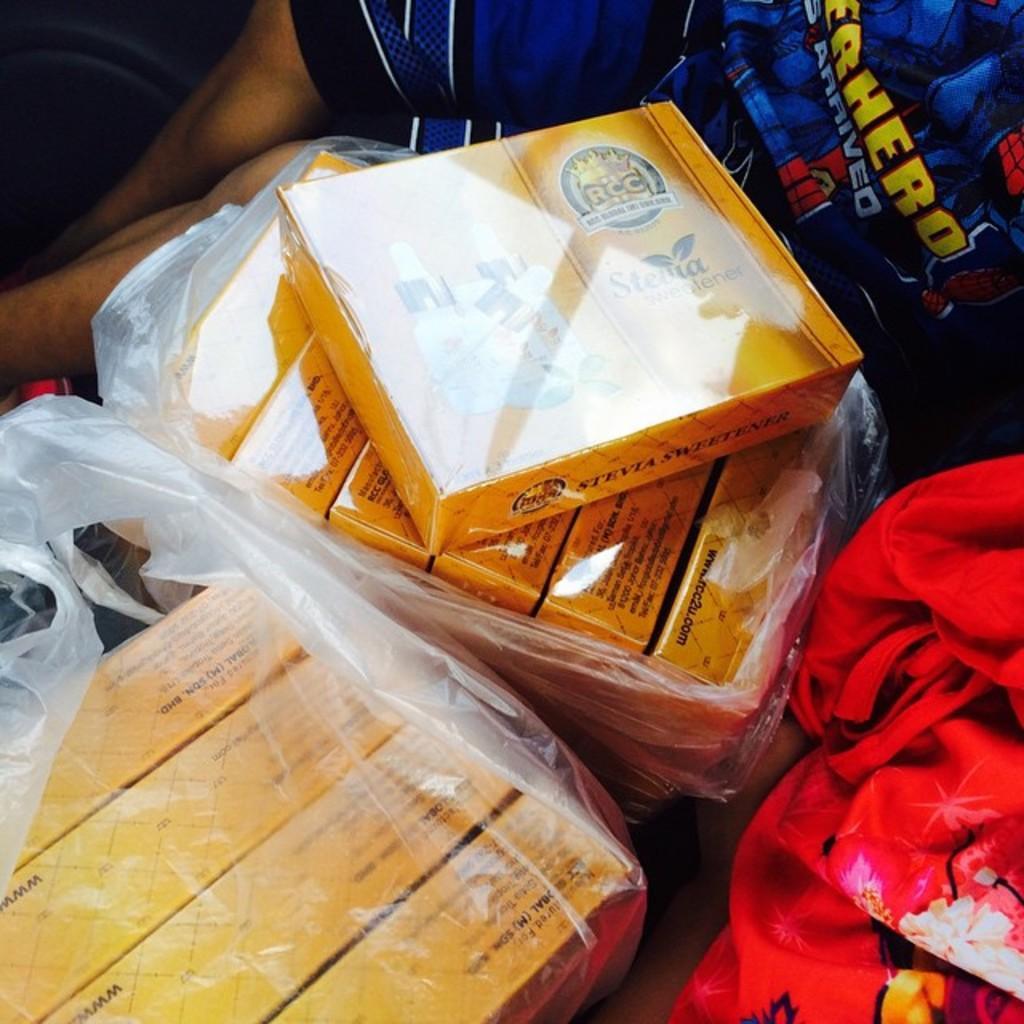How would you summarize this image in a sentence or two? In the image in the center, we can see boxes, plastic covers and one cloth. In the background we can see one person sitting. 